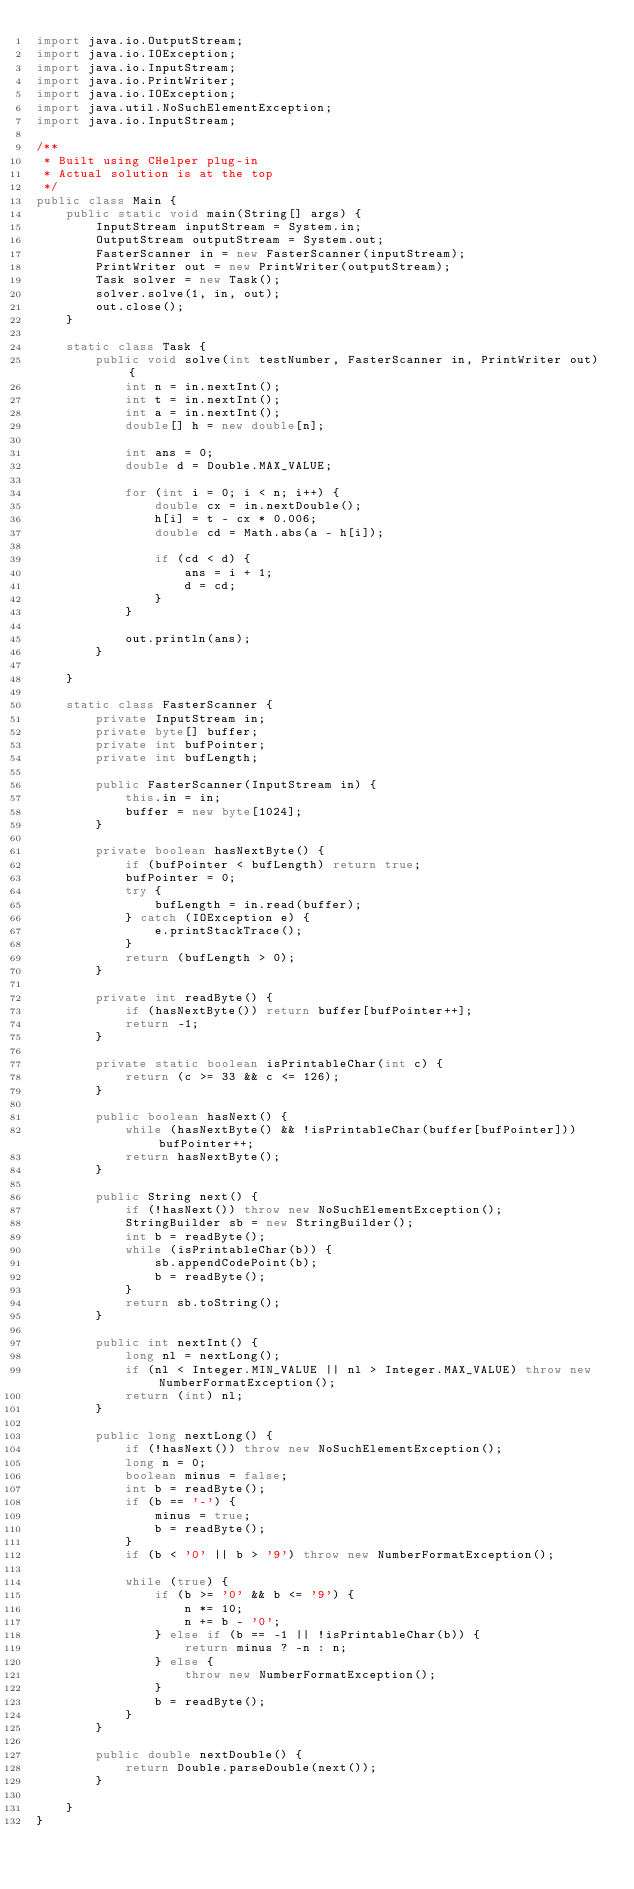<code> <loc_0><loc_0><loc_500><loc_500><_Java_>import java.io.OutputStream;
import java.io.IOException;
import java.io.InputStream;
import java.io.PrintWriter;
import java.io.IOException;
import java.util.NoSuchElementException;
import java.io.InputStream;

/**
 * Built using CHelper plug-in
 * Actual solution is at the top
 */
public class Main {
    public static void main(String[] args) {
        InputStream inputStream = System.in;
        OutputStream outputStream = System.out;
        FasterScanner in = new FasterScanner(inputStream);
        PrintWriter out = new PrintWriter(outputStream);
        Task solver = new Task();
        solver.solve(1, in, out);
        out.close();
    }

    static class Task {
        public void solve(int testNumber, FasterScanner in, PrintWriter out) {
            int n = in.nextInt();
            int t = in.nextInt();
            int a = in.nextInt();
            double[] h = new double[n];

            int ans = 0;
            double d = Double.MAX_VALUE;

            for (int i = 0; i < n; i++) {
                double cx = in.nextDouble();
                h[i] = t - cx * 0.006;
                double cd = Math.abs(a - h[i]);

                if (cd < d) {
                    ans = i + 1;
                    d = cd;
                }
            }

            out.println(ans);
        }

    }

    static class FasterScanner {
        private InputStream in;
        private byte[] buffer;
        private int bufPointer;
        private int bufLength;

        public FasterScanner(InputStream in) {
            this.in = in;
            buffer = new byte[1024];
        }

        private boolean hasNextByte() {
            if (bufPointer < bufLength) return true;
            bufPointer = 0;
            try {
                bufLength = in.read(buffer);
            } catch (IOException e) {
                e.printStackTrace();
            }
            return (bufLength > 0);
        }

        private int readByte() {
            if (hasNextByte()) return buffer[bufPointer++];
            return -1;
        }

        private static boolean isPrintableChar(int c) {
            return (c >= 33 && c <= 126);
        }

        public boolean hasNext() {
            while (hasNextByte() && !isPrintableChar(buffer[bufPointer])) bufPointer++;
            return hasNextByte();
        }

        public String next() {
            if (!hasNext()) throw new NoSuchElementException();
            StringBuilder sb = new StringBuilder();
            int b = readByte();
            while (isPrintableChar(b)) {
                sb.appendCodePoint(b);
                b = readByte();
            }
            return sb.toString();
        }

        public int nextInt() {
            long nl = nextLong();
            if (nl < Integer.MIN_VALUE || nl > Integer.MAX_VALUE) throw new NumberFormatException();
            return (int) nl;
        }

        public long nextLong() {
            if (!hasNext()) throw new NoSuchElementException();
            long n = 0;
            boolean minus = false;
            int b = readByte();
            if (b == '-') {
                minus = true;
                b = readByte();
            }
            if (b < '0' || b > '9') throw new NumberFormatException();

            while (true) {
                if (b >= '0' && b <= '9') {
                    n *= 10;
                    n += b - '0';
                } else if (b == -1 || !isPrintableChar(b)) {
                    return minus ? -n : n;
                } else {
                    throw new NumberFormatException();
                }
                b = readByte();
            }
        }

        public double nextDouble() {
            return Double.parseDouble(next());
        }

    }
}

</code> 